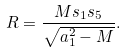Convert formula to latex. <formula><loc_0><loc_0><loc_500><loc_500>R = \frac { M s _ { 1 } s _ { 5 } } { \sqrt { a _ { 1 } ^ { 2 } - M } } .</formula> 